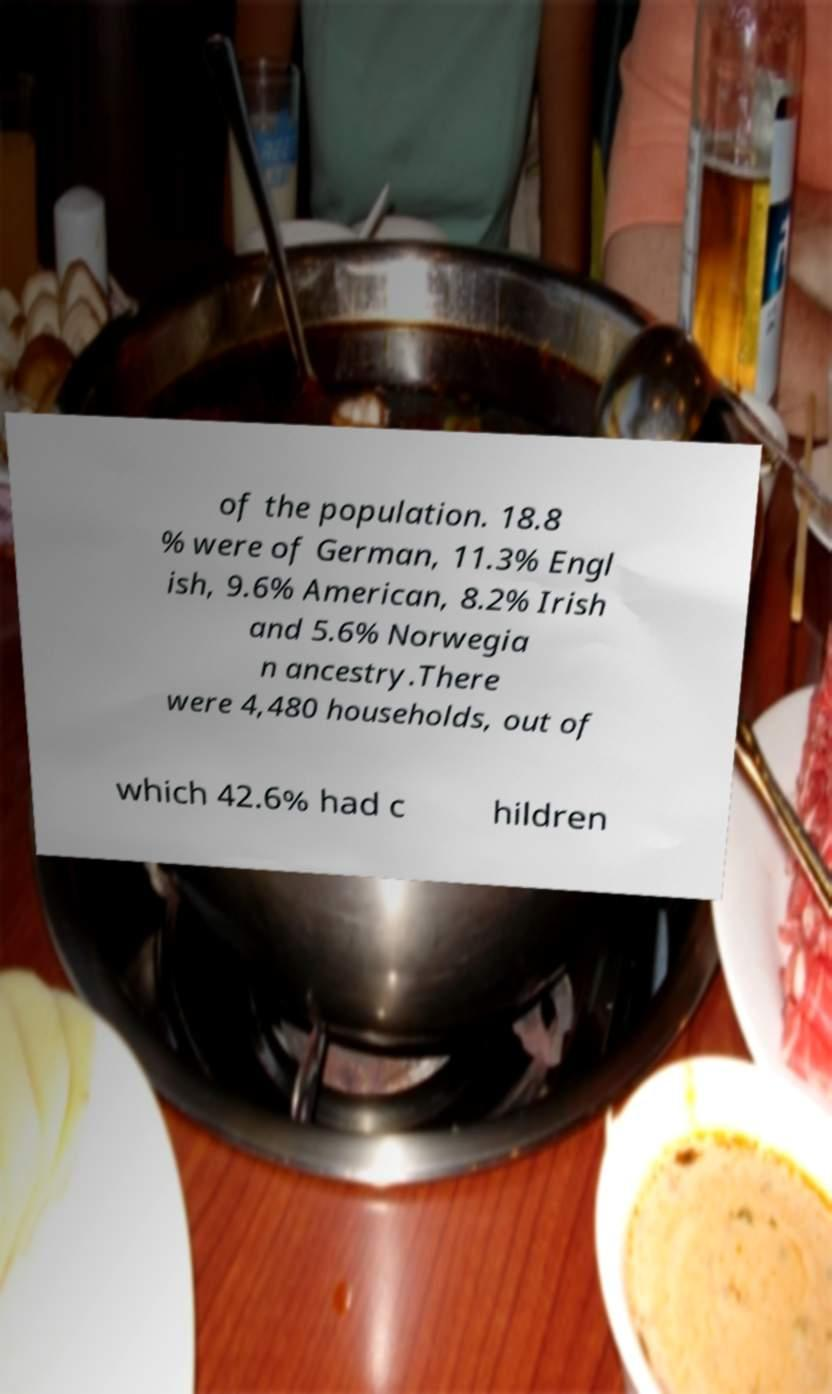There's text embedded in this image that I need extracted. Can you transcribe it verbatim? of the population. 18.8 % were of German, 11.3% Engl ish, 9.6% American, 8.2% Irish and 5.6% Norwegia n ancestry.There were 4,480 households, out of which 42.6% had c hildren 